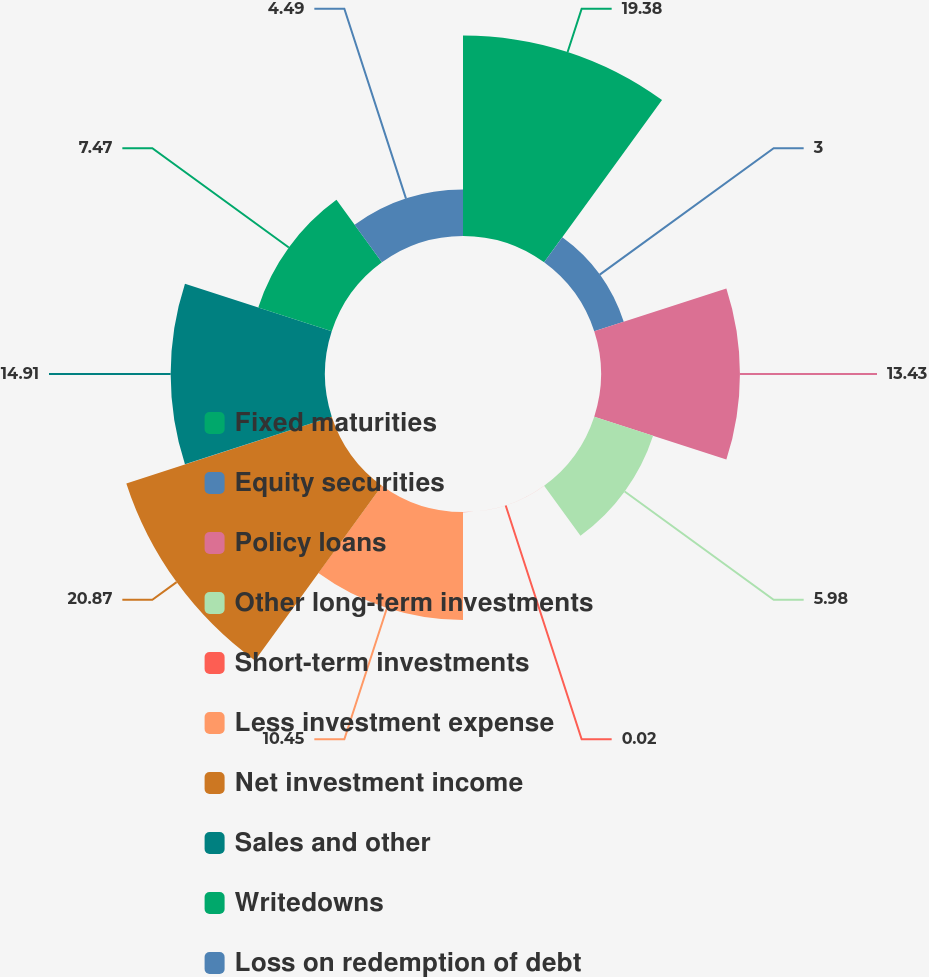<chart> <loc_0><loc_0><loc_500><loc_500><pie_chart><fcel>Fixed maturities<fcel>Equity securities<fcel>Policy loans<fcel>Other long-term investments<fcel>Short-term investments<fcel>Less investment expense<fcel>Net investment income<fcel>Sales and other<fcel>Writedowns<fcel>Loss on redemption of debt<nl><fcel>19.39%<fcel>3.0%<fcel>13.43%<fcel>5.98%<fcel>0.02%<fcel>10.45%<fcel>20.88%<fcel>14.92%<fcel>7.47%<fcel>4.49%<nl></chart> 